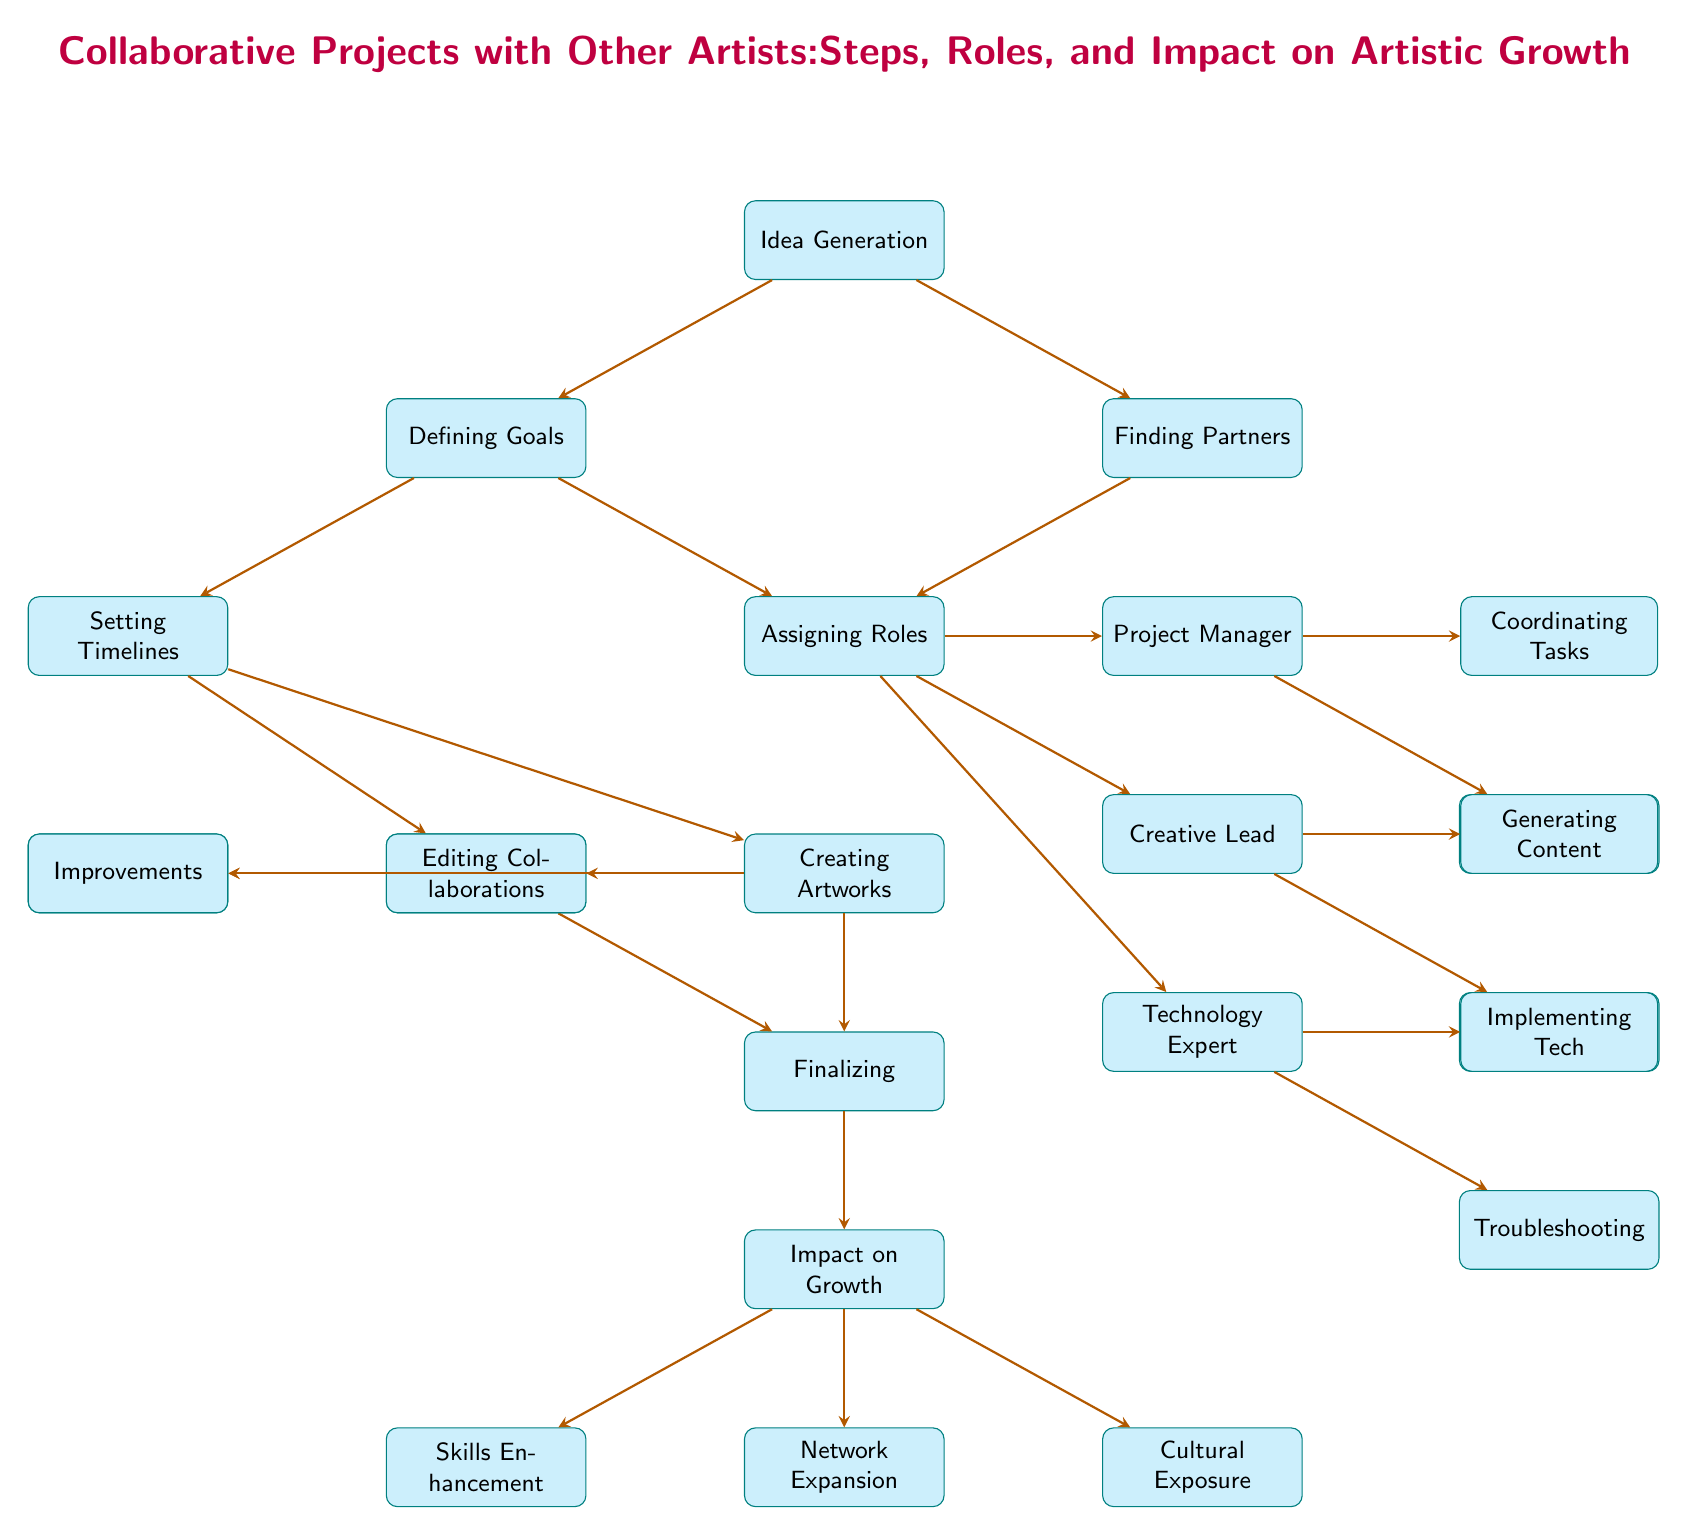What is the first step in collaborative projects? The diagram shows that the first step in collaborative projects is "Idea Generation," which is the starting point for the entire process.
Answer: Idea Generation How many impact nodes are listed in the diagram? By counting the nodes connected under the "Impact on Growth," there are three nodes: "Skills Enhancement," "Network Expansion," and "Cultural Exposure."
Answer: 3 What follows "Defining Goals" in the collaborative project flow? The diagram indicates that after "Defining Goals," the next steps are "Setting Timelines" and "Assigning Roles," showcasing that these activities depend on the established goals.
Answer: Setting Timelines, Assigning Roles Which role is responsible for "Coordinating Tasks"? According to the diagram, the "Project Manager" role is responsible for "Coordinating Tasks" as indicated through the arrows leading from "Assigning Roles" to the "Project Manager."
Answer: Project Manager How do "Creating Artworks" and "Review & Feedback" relate to the final stages of the project? The diagram illustrates that both "Creating Artworks" and "Review & Feedback" lead to "Finalizing," which is a critical step before assessing the overall impact of the project on artistic growth.
Answer: They lead to Finalizing What step comes directly after "Finding Partners"? The flow in the diagram shows that "Assigning Roles" is the step that directly follows "Finding Partners," indicating that partnership formation leads to defining roles within the project.
Answer: Assigning Roles In what way does "Impact on Growth" contribute to "Skills Enhancement"? The diagram represents "Impact on Growth" as the last node that connects downwards to "Skills Enhancement," demonstrating that the overall impact of collaboration leads to this specific enhancement in skills.
Answer: By leading to Skills Enhancement Which role has the responsibility of "Implementing Tech"? The diagram specifies that the "Technology Expert" is tasked with "Implementing Tech," confirming their integral role in tech-related aspects of the collaborative project.
Answer: Technology Expert What is the last step in the collaborative project flow? The final step in the diagram is "Impact on Growth," which signifies the outcome and benefits derived from completing all previous steps in the collaborative process.
Answer: Impact on Growth 